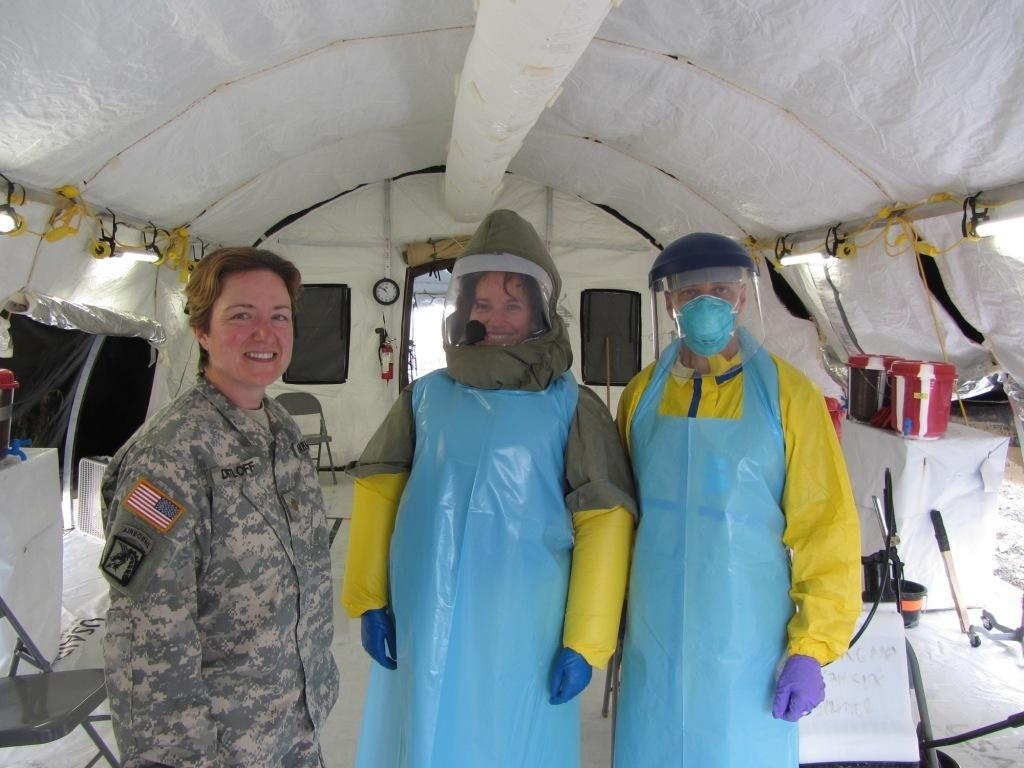How many people are present in the image? There are three people in the image. Where are the people located? The people are standing inside a tent. Can you describe the clothing of one of the people? One of the people is wearing an army uniform. What type of furniture can be seen in the image? There are chairs and a table in the image. What other object is present in the image? There is a clock in the image. What type of cabbage is being served on the pie in the image? There is no cabbage or pie present in the image. How many bears can be seen interacting with the people in the image? There are no bears present in the image. 